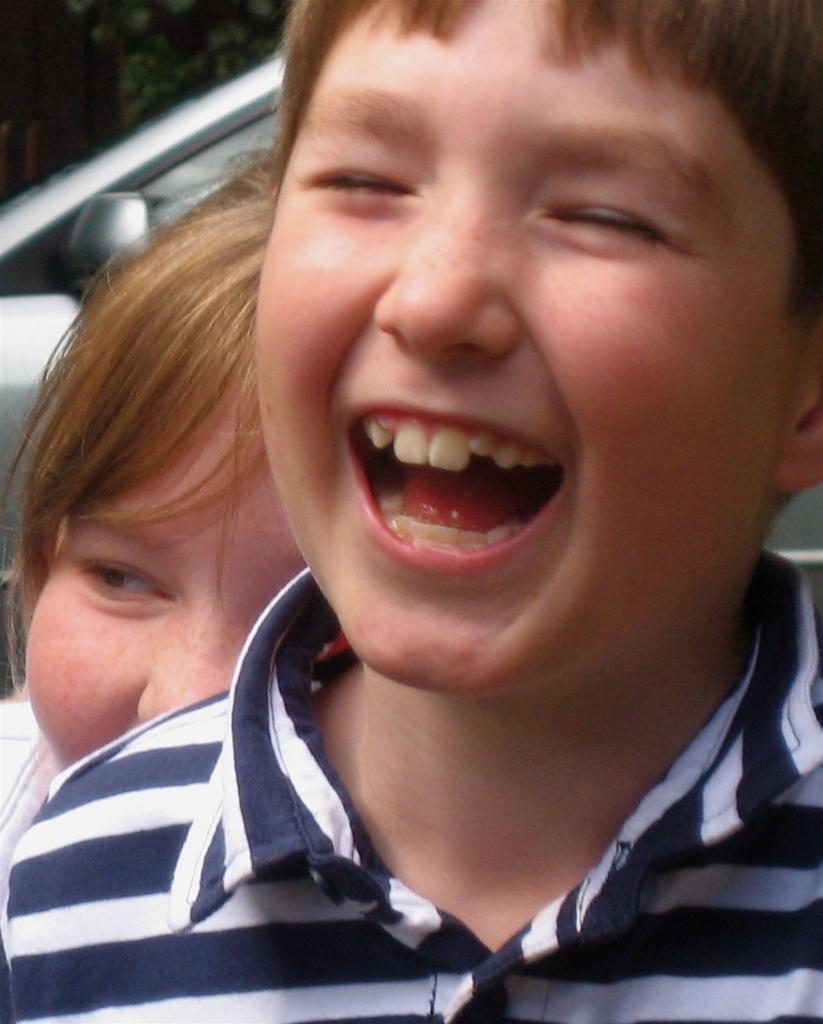How would you summarize this image in a sentence or two? In this image in the foreground there is one boy who is smiling, and in the background there is another boy and some object. 